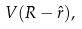Convert formula to latex. <formula><loc_0><loc_0><loc_500><loc_500>V ( { R } - \hat { r } ) ,</formula> 